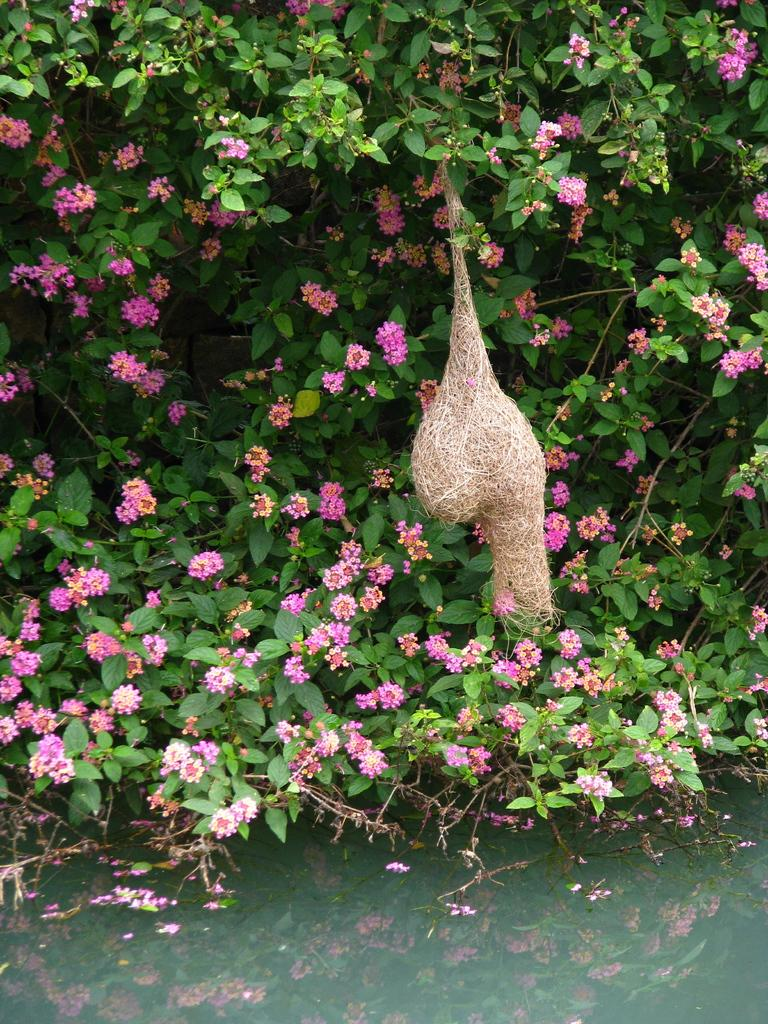What is visible in the image? Water is visible in the image. What can be seen on the tree in the image? There are flowers on a tree and a bird nest on a tree. What type of bean is growing on the tree in the image? There are no beans present on the tree in the image; it has flowers and a bird nest. What holiday is being celebrated in the image? There is no indication of a holiday being celebrated in the image. 